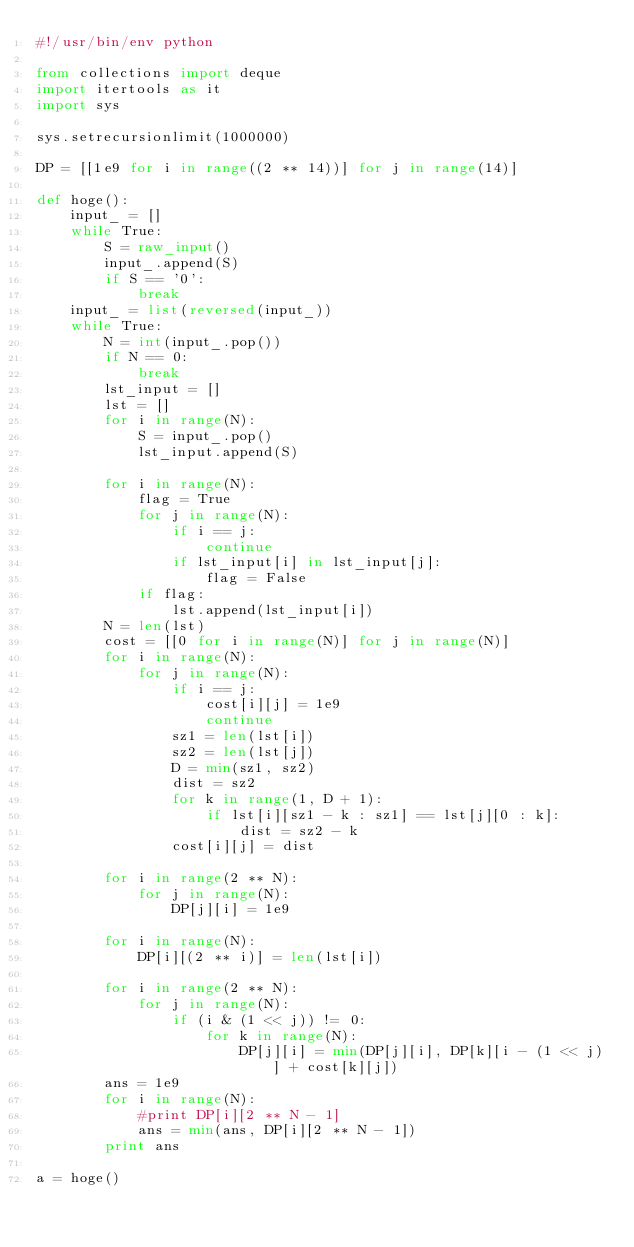<code> <loc_0><loc_0><loc_500><loc_500><_Python_>#!/usr/bin/env python

from collections import deque
import itertools as it
import sys

sys.setrecursionlimit(1000000)

DP = [[1e9 for i in range((2 ** 14))] for j in range(14)]

def hoge():
    input_ = []
    while True:
        S = raw_input()
        input_.append(S)
        if S == '0':
            break
    input_ = list(reversed(input_))
    while True:
        N = int(input_.pop())
        if N == 0:
            break
        lst_input = []
        lst = []
        for i in range(N):
            S = input_.pop()
            lst_input.append(S)
        
        for i in range(N):
            flag = True
            for j in range(N):
                if i == j:
                    continue
                if lst_input[i] in lst_input[j]:
                    flag = False
            if flag:
                lst.append(lst_input[i])
        N = len(lst)
        cost = [[0 for i in range(N)] for j in range(N)]
        for i in range(N):
            for j in range(N):
                if i == j:
                    cost[i][j] = 1e9
                    continue
                sz1 = len(lst[i])
                sz2 = len(lst[j])
                D = min(sz1, sz2)
                dist = sz2
                for k in range(1, D + 1):
                    if lst[i][sz1 - k : sz1] == lst[j][0 : k]:
                        dist = sz2 - k
                cost[i][j] = dist
        
        for i in range(2 ** N):
            for j in range(N):
                DP[j][i] = 1e9
        
        for i in range(N):
            DP[i][(2 ** i)] = len(lst[i])
        
        for i in range(2 ** N):
            for j in range(N):
                if (i & (1 << j)) != 0:
                    for k in range(N):
                        DP[j][i] = min(DP[j][i], DP[k][i - (1 << j)] + cost[k][j])
        ans = 1e9
        for i in range(N):
            #print DP[i][2 ** N - 1]
            ans = min(ans, DP[i][2 ** N - 1])
        print ans

a = hoge()
</code> 